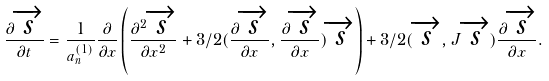Convert formula to latex. <formula><loc_0><loc_0><loc_500><loc_500>\frac { \partial \overrightarrow { s } } { \partial t } = \frac { 1 } { a _ { n } ^ { ( 1 ) } } \frac { \partial } { \partial x } \left ( \frac { \partial ^ { 2 } \overrightarrow { s } } { \partial x ^ { 2 } } + 3 / 2 ( \frac { \partial \overrightarrow { s } } { \partial x } , \frac { \partial \overrightarrow { s } } { \partial x } ) \overrightarrow { s } \right ) + 3 / 2 ( \overrightarrow { s } , { J } \overrightarrow { s } ) \frac { \partial \overrightarrow { s } } { \partial x } .</formula> 